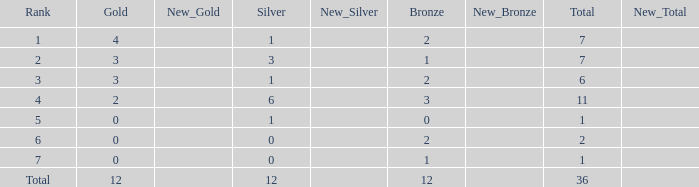What is the number of bronze medals when there are fewer than 0 silver medals? None. 